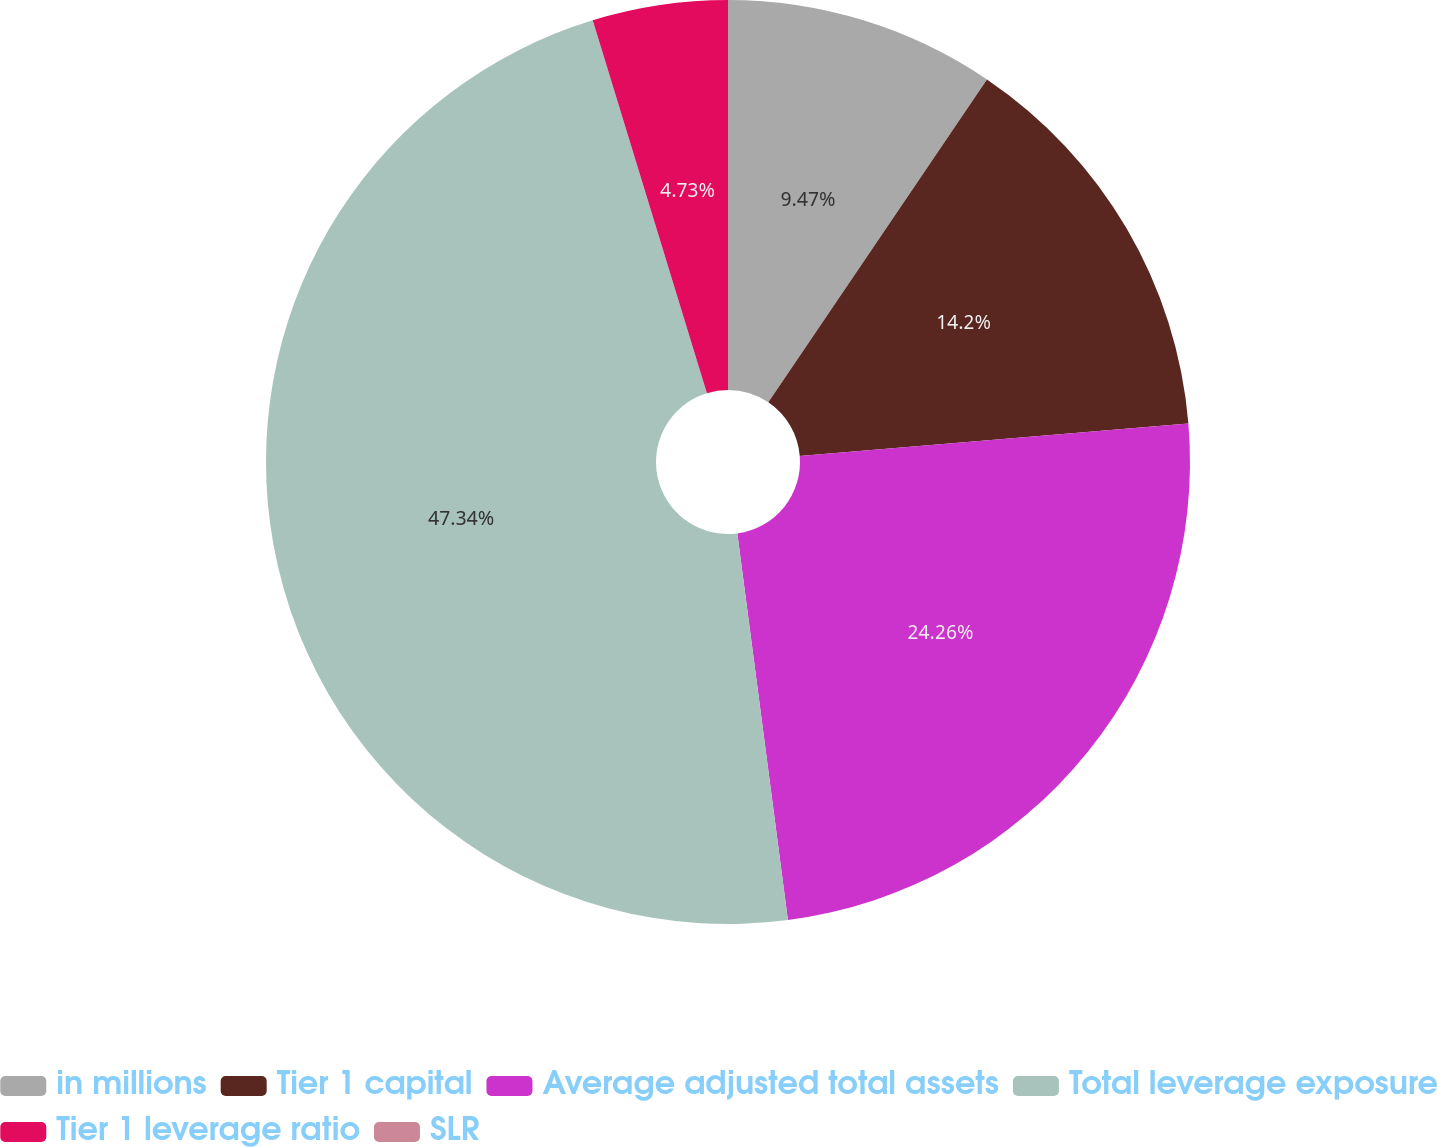<chart> <loc_0><loc_0><loc_500><loc_500><pie_chart><fcel>in millions<fcel>Tier 1 capital<fcel>Average adjusted total assets<fcel>Total leverage exposure<fcel>Tier 1 leverage ratio<fcel>SLR<nl><fcel>9.47%<fcel>14.2%<fcel>24.26%<fcel>47.34%<fcel>4.73%<fcel>0.0%<nl></chart> 